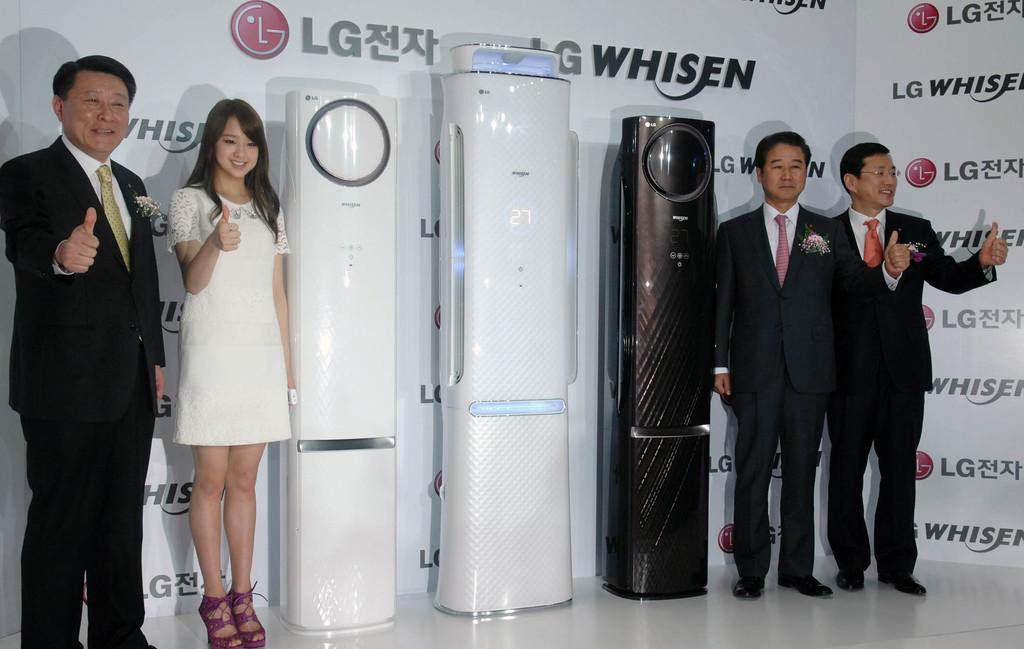Can you describe this image briefly? In this image there are three electronic devices in the middle. on both side there are two people each. The men are wearing suits. The lady is wearing white dress. In the background there is banner. 